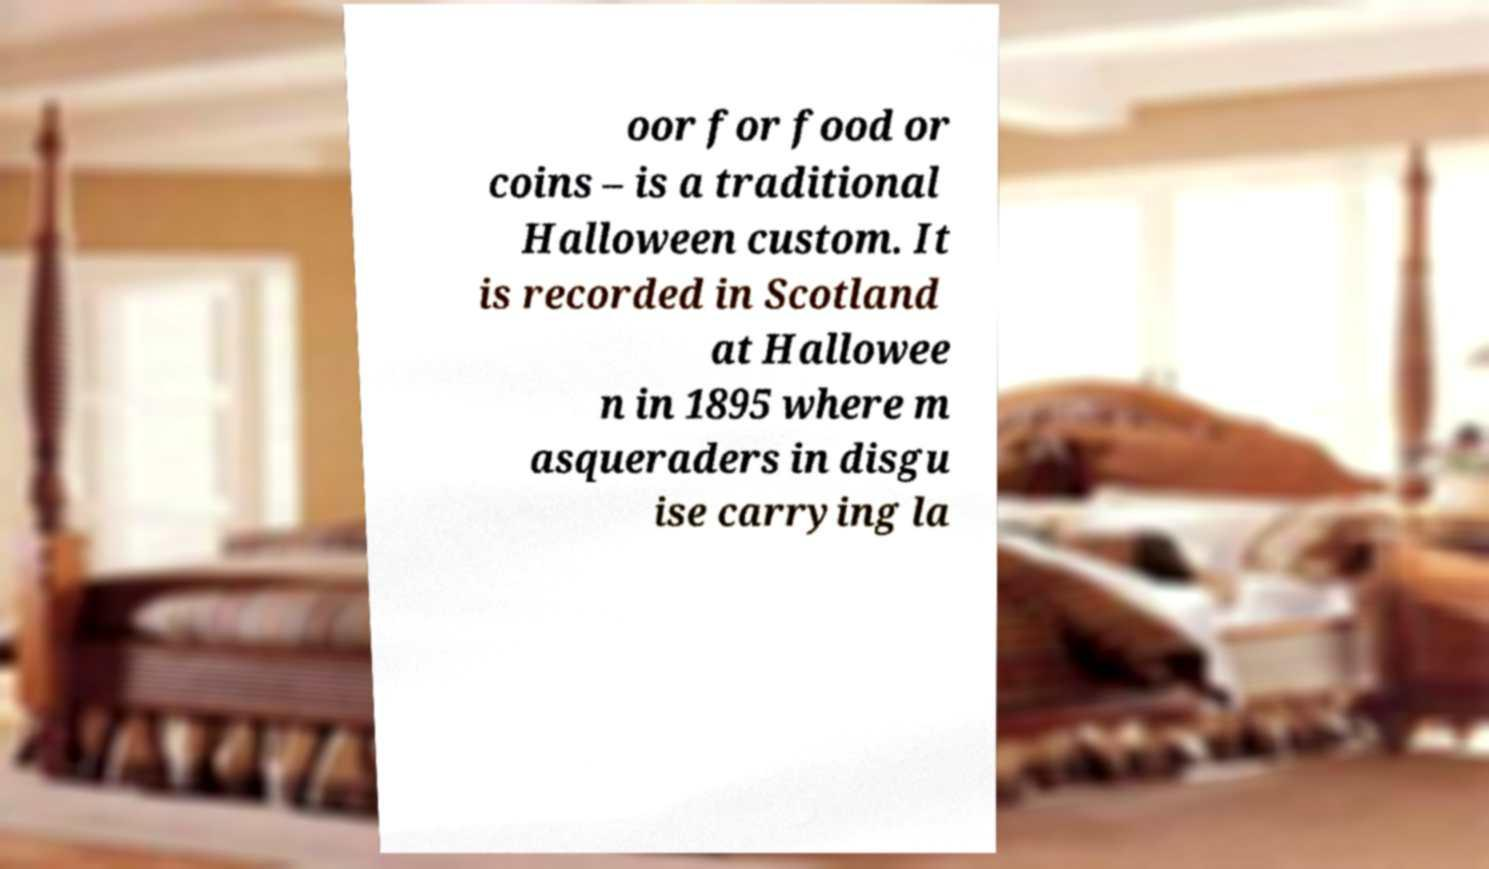For documentation purposes, I need the text within this image transcribed. Could you provide that? oor for food or coins – is a traditional Halloween custom. It is recorded in Scotland at Hallowee n in 1895 where m asqueraders in disgu ise carrying la 